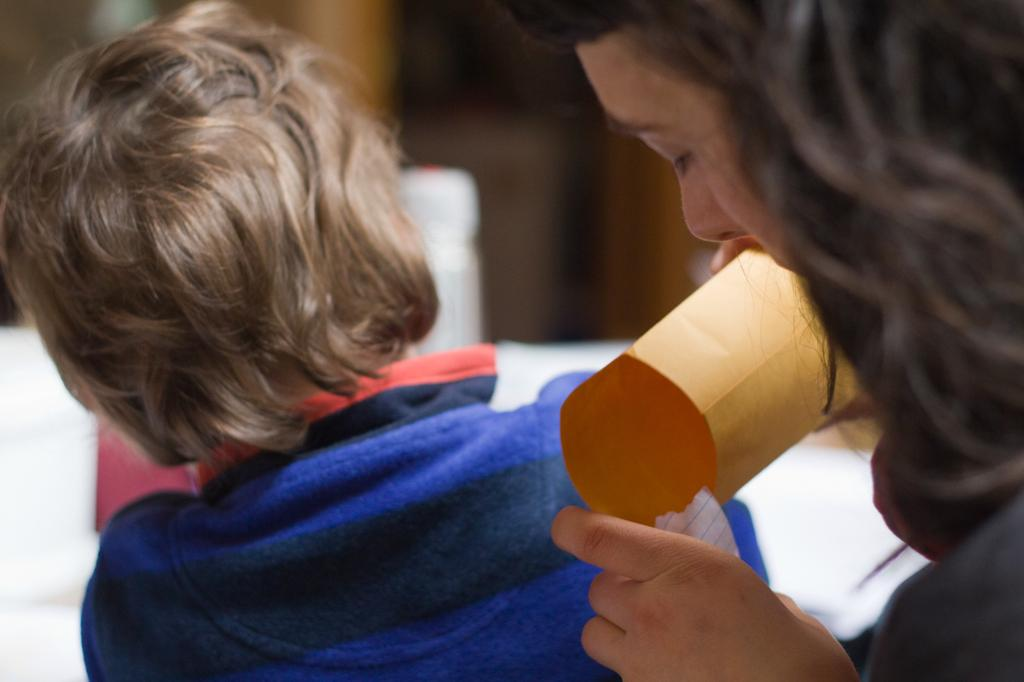Who is present in the image? There is a woman and a kid in the image. What is the woman holding? The woman is holding a paper. Can you describe the background of the image? The background of the image is blurry. What type of pollution can be seen in the image? There is no pollution visible in the image. What government policies are being discussed in the image? There is no discussion of government policies in the image. 